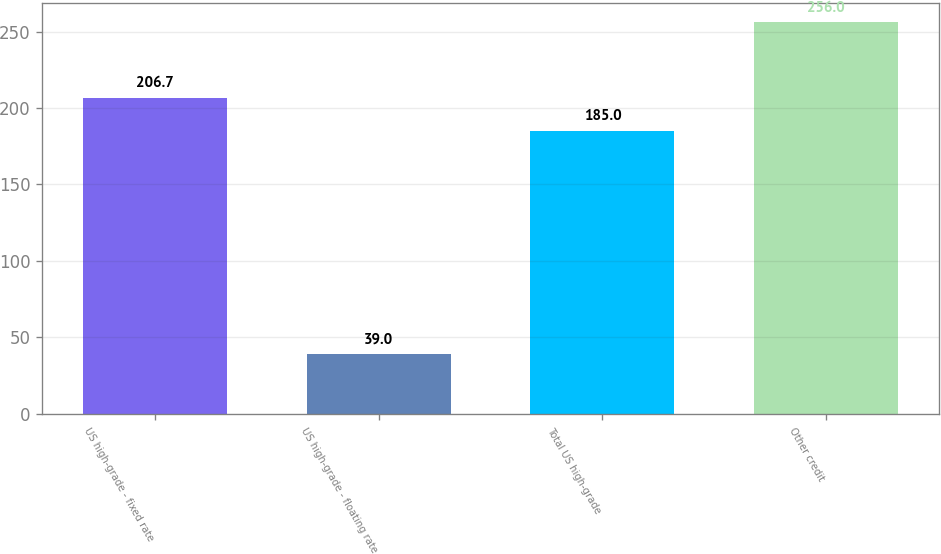Convert chart. <chart><loc_0><loc_0><loc_500><loc_500><bar_chart><fcel>US high-grade - fixed rate<fcel>US high-grade - floating rate<fcel>Total US high-grade<fcel>Other credit<nl><fcel>206.7<fcel>39<fcel>185<fcel>256<nl></chart> 